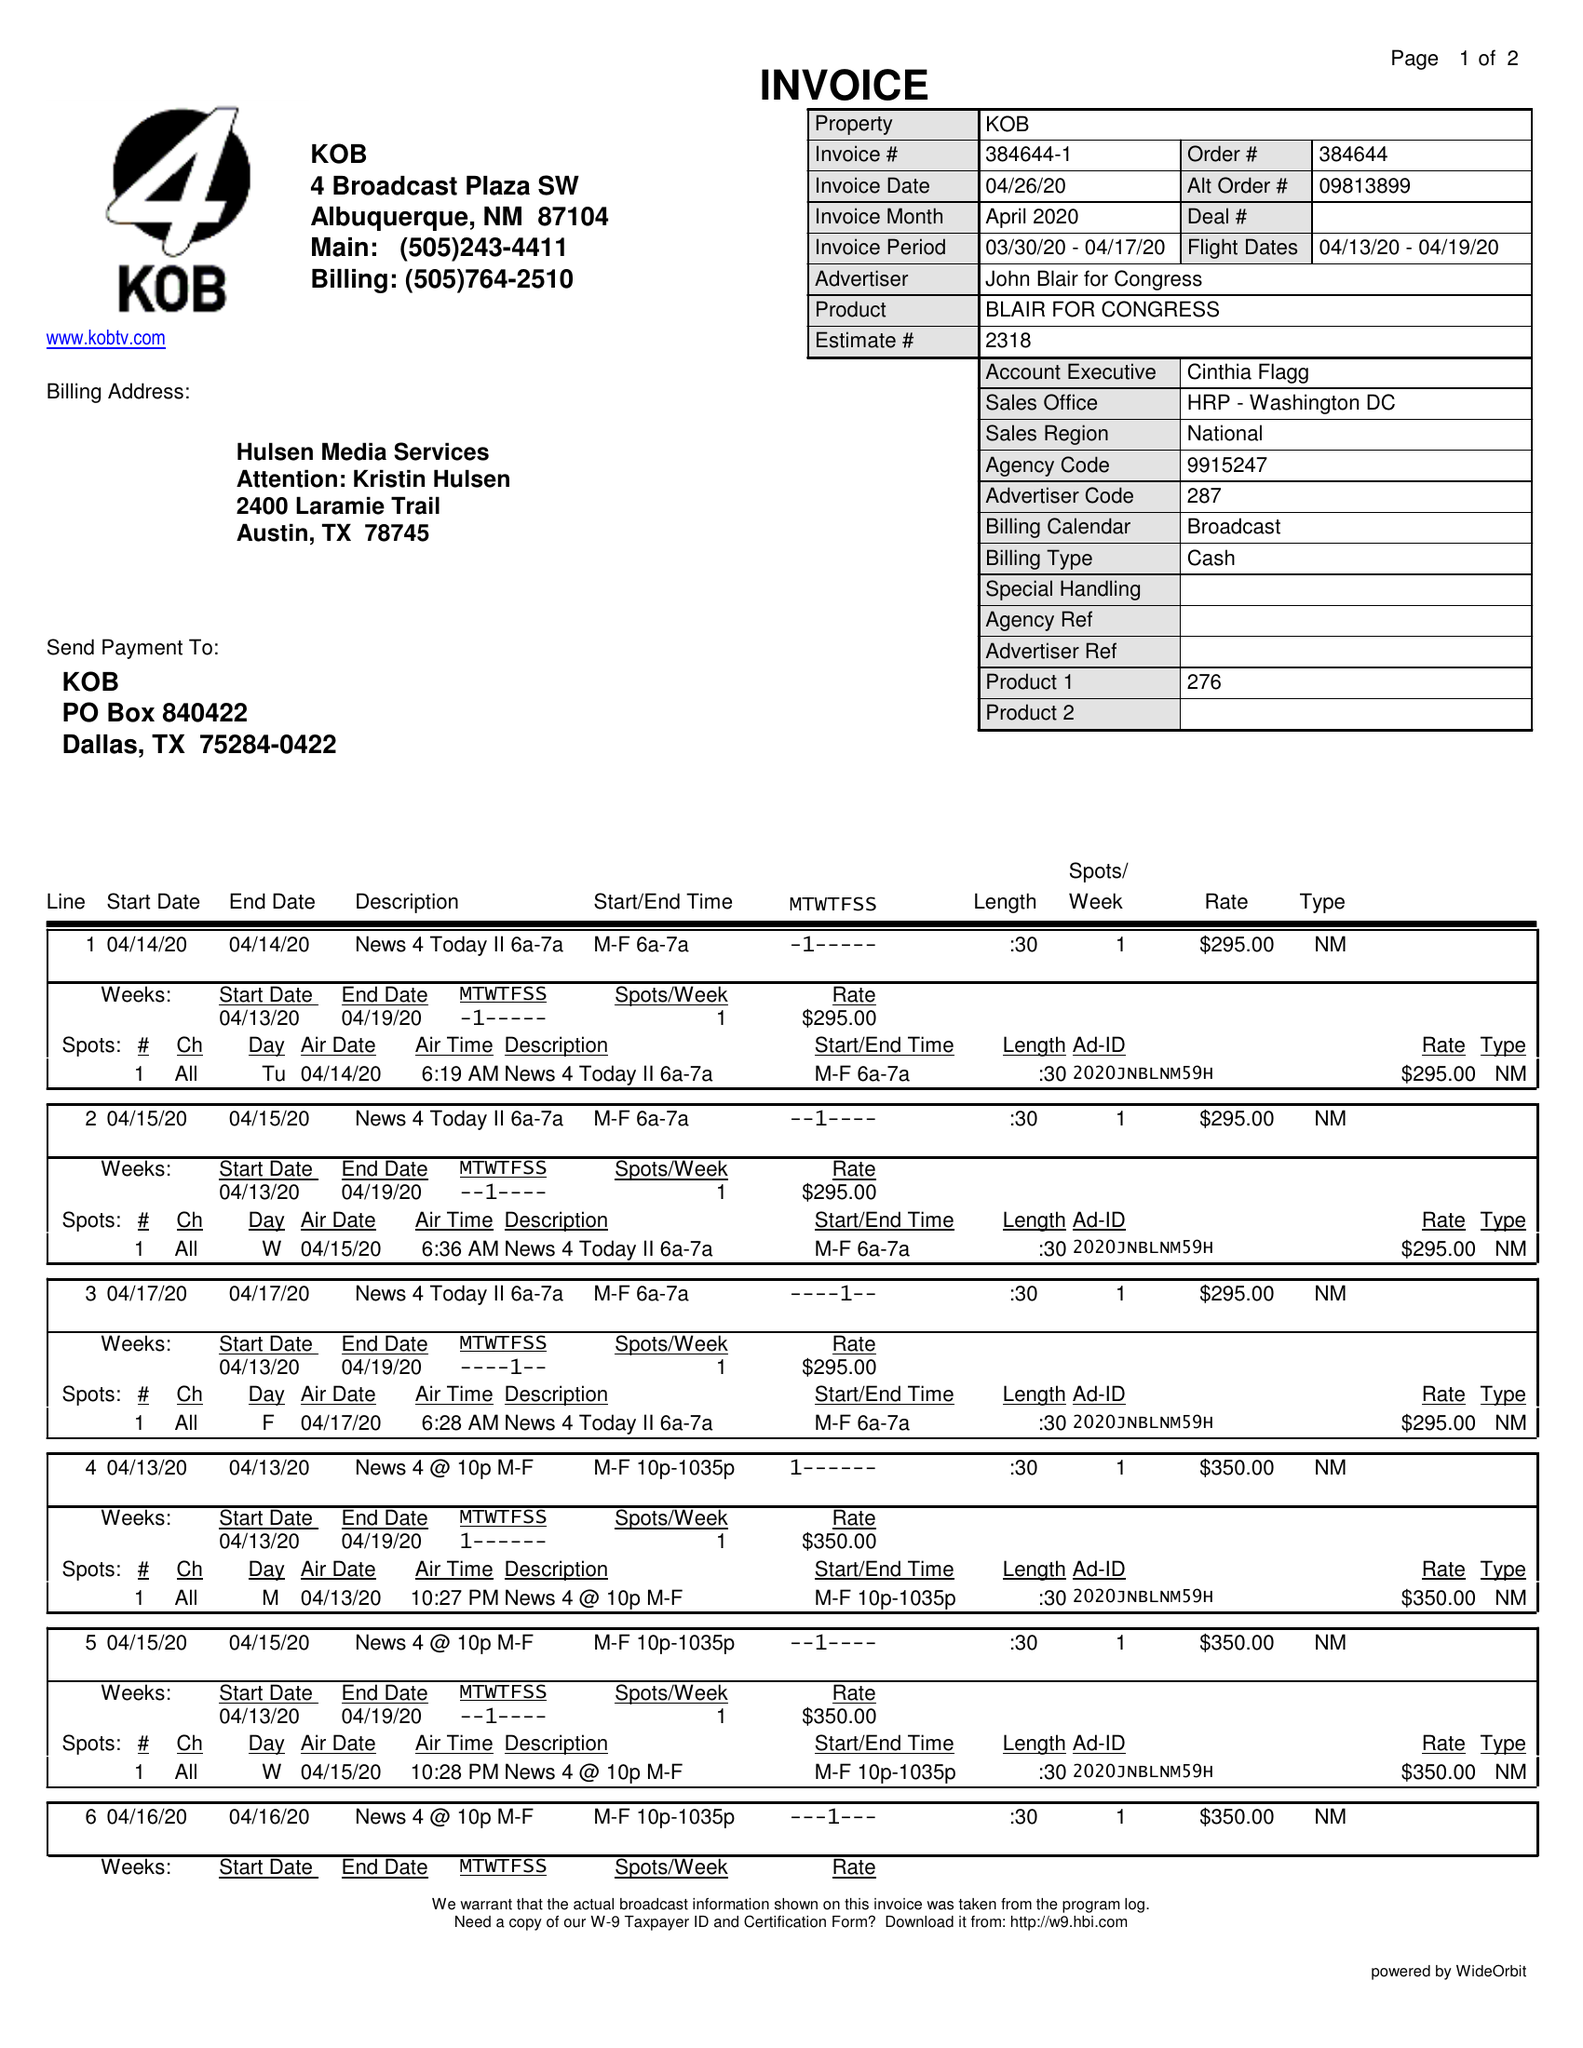What is the value for the advertiser?
Answer the question using a single word or phrase. JOHN BLAIR FOR CONGRESS 